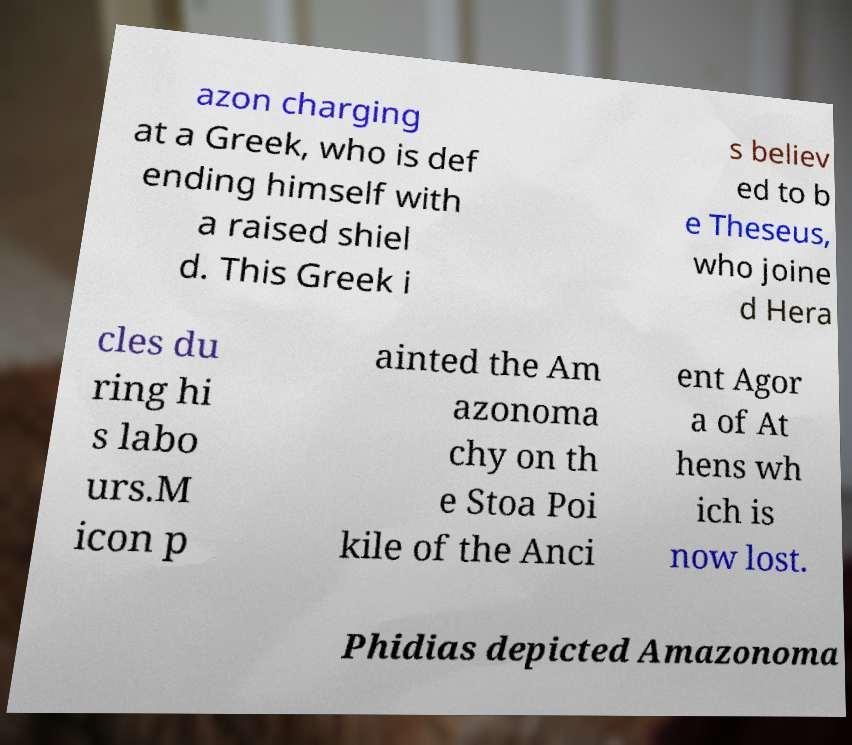Can you read and provide the text displayed in the image?This photo seems to have some interesting text. Can you extract and type it out for me? azon charging at a Greek, who is def ending himself with a raised shiel d. This Greek i s believ ed to b e Theseus, who joine d Hera cles du ring hi s labo urs.M icon p ainted the Am azonoma chy on th e Stoa Poi kile of the Anci ent Agor a of At hens wh ich is now lost. Phidias depicted Amazonoma 